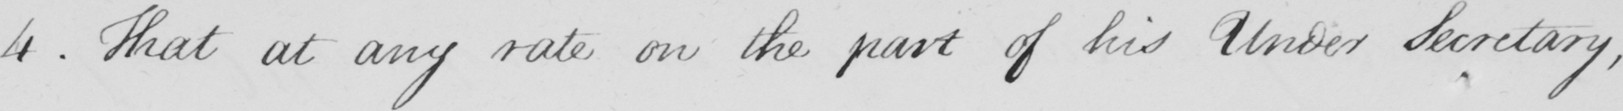Transcribe the text shown in this historical manuscript line. 4 . That at any rate on the part of his Under Secretary , 